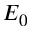<formula> <loc_0><loc_0><loc_500><loc_500>E _ { 0 }</formula> 